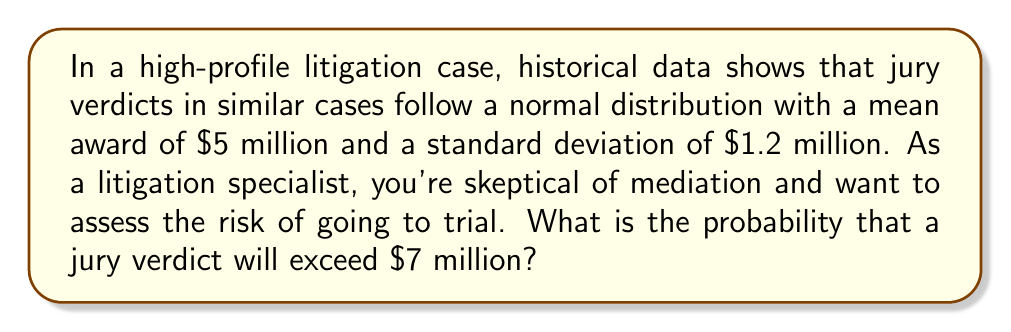Could you help me with this problem? Let's approach this step-by-step:

1) We're given that the jury verdicts follow a normal distribution with:
   $\mu = 5$ million
   $\sigma = 1.2$ million

2) We want to find $P(X > 7)$, where $X$ is the jury verdict in millions of dollars.

3) To solve this, we need to standardize the random variable:
   $$Z = \frac{X - \mu}{\sigma} = \frac{7 - 5}{1.2} = \frac{2}{1.2} \approx 1.67$$

4) Now we need to find $P(Z > 1.67)$

5) Using the standard normal distribution table or a calculator, we can find:
   $P(Z < 1.67) \approx 0.9525$

6) Since we want the probability of exceeding 7 million, we calculate:
   $P(Z > 1.67) = 1 - P(Z < 1.67) = 1 - 0.9525 = 0.0475$

7) Therefore, the probability of a jury verdict exceeding $7 million is approximately 0.0475 or 4.75%.

This low probability might reinforce your skepticism about mediation, as there's only about a 4.75% chance of getting a verdict higher than $7 million by going to trial.
Answer: 0.0475 or 4.75% 